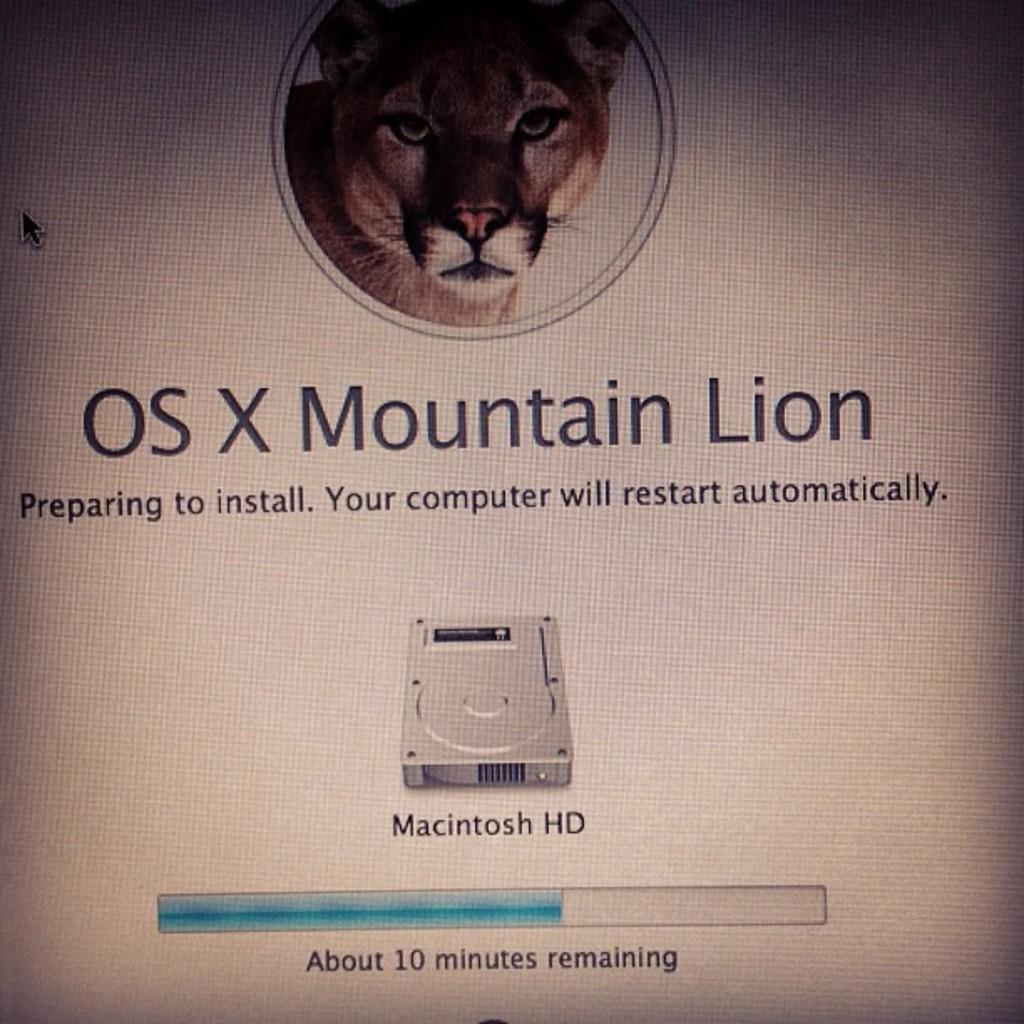What electronic device is present in the image? There is a monitor in the image. What is displayed on the monitor screen? The monitor screen displays a lion. Are there any words or characters visible on the monitor screen? Yes, there is text visible on the monitor screen. What type of camera is being used to capture the image of the parent cooking on the stove? There is no camera or stove present in the image; it only features a monitor displaying a lion with text. 